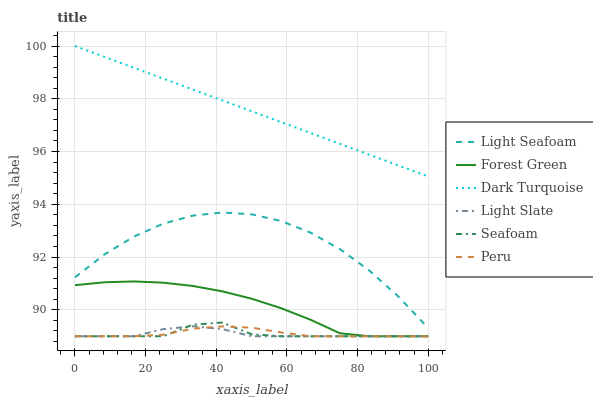Does Light Slate have the minimum area under the curve?
Answer yes or no. Yes. Does Dark Turquoise have the maximum area under the curve?
Answer yes or no. Yes. Does Seafoam have the minimum area under the curve?
Answer yes or no. No. Does Seafoam have the maximum area under the curve?
Answer yes or no. No. Is Dark Turquoise the smoothest?
Answer yes or no. Yes. Is Light Seafoam the roughest?
Answer yes or no. Yes. Is Seafoam the smoothest?
Answer yes or no. No. Is Seafoam the roughest?
Answer yes or no. No. Does Dark Turquoise have the lowest value?
Answer yes or no. No. Does Dark Turquoise have the highest value?
Answer yes or no. Yes. Does Seafoam have the highest value?
Answer yes or no. No. Is Forest Green less than Dark Turquoise?
Answer yes or no. Yes. Is Dark Turquoise greater than Light Slate?
Answer yes or no. Yes. Does Seafoam intersect Light Slate?
Answer yes or no. Yes. Is Seafoam less than Light Slate?
Answer yes or no. No. Is Seafoam greater than Light Slate?
Answer yes or no. No. Does Forest Green intersect Dark Turquoise?
Answer yes or no. No. 